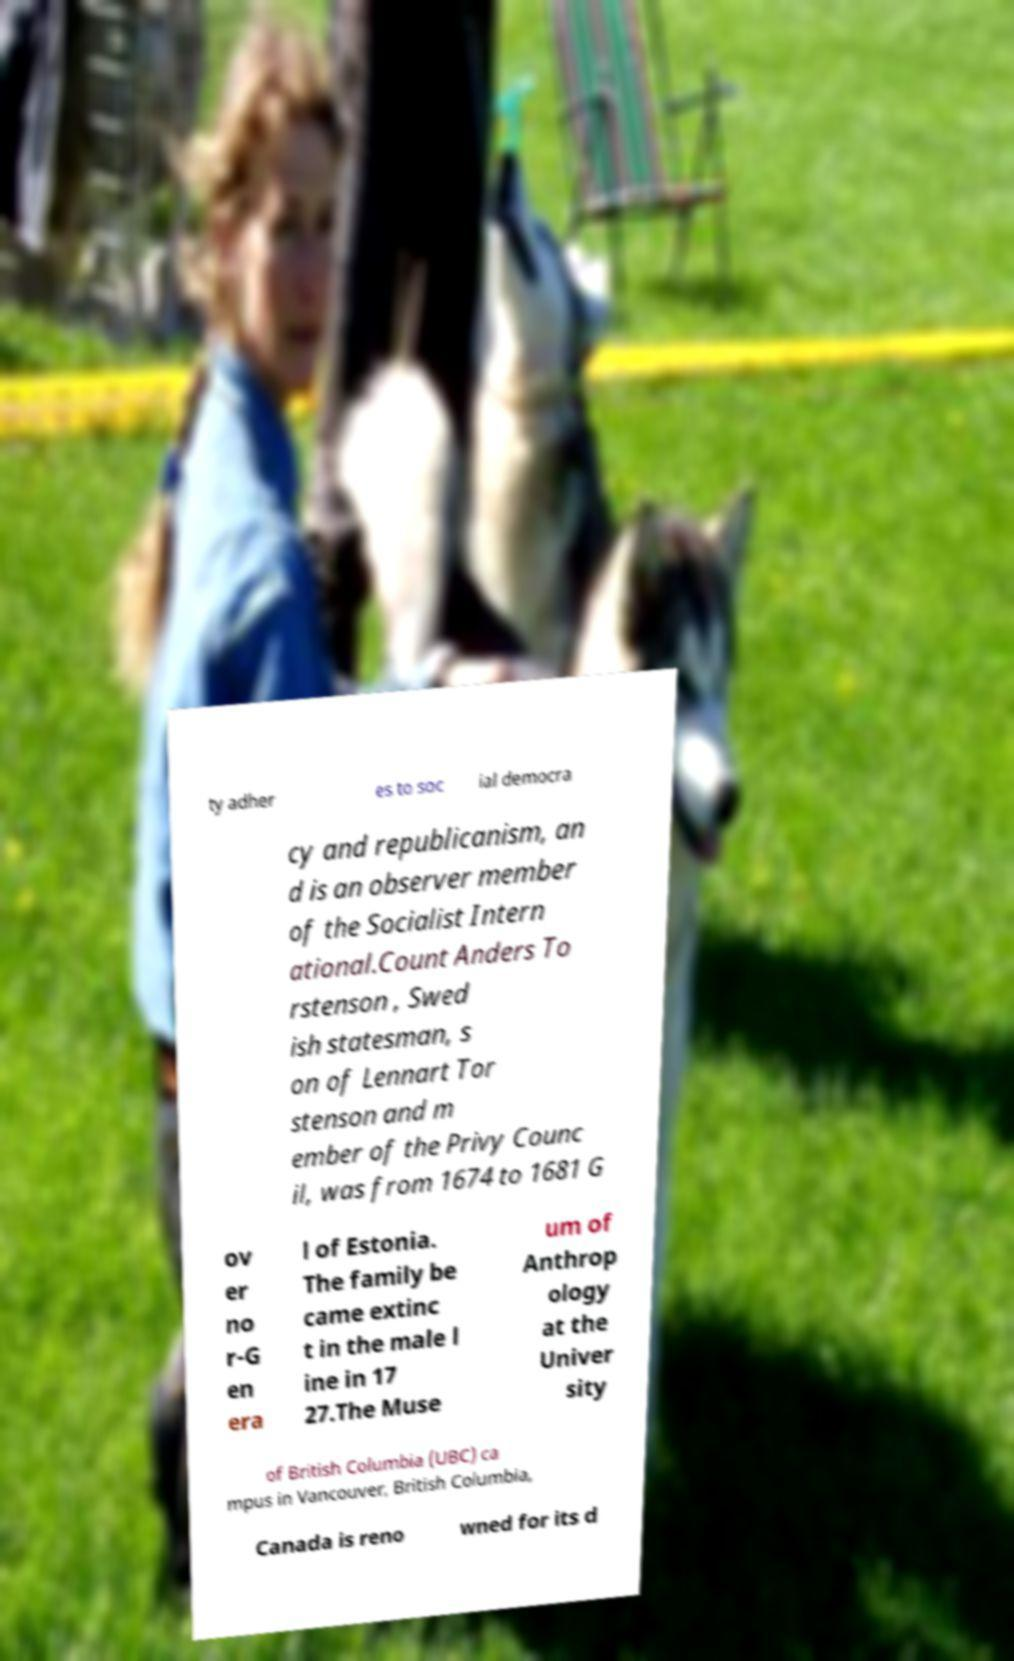Please identify and transcribe the text found in this image. ty adher es to soc ial democra cy and republicanism, an d is an observer member of the Socialist Intern ational.Count Anders To rstenson , Swed ish statesman, s on of Lennart Tor stenson and m ember of the Privy Counc il, was from 1674 to 1681 G ov er no r-G en era l of Estonia. The family be came extinc t in the male l ine in 17 27.The Muse um of Anthrop ology at the Univer sity of British Columbia (UBC) ca mpus in Vancouver, British Columbia, Canada is reno wned for its d 